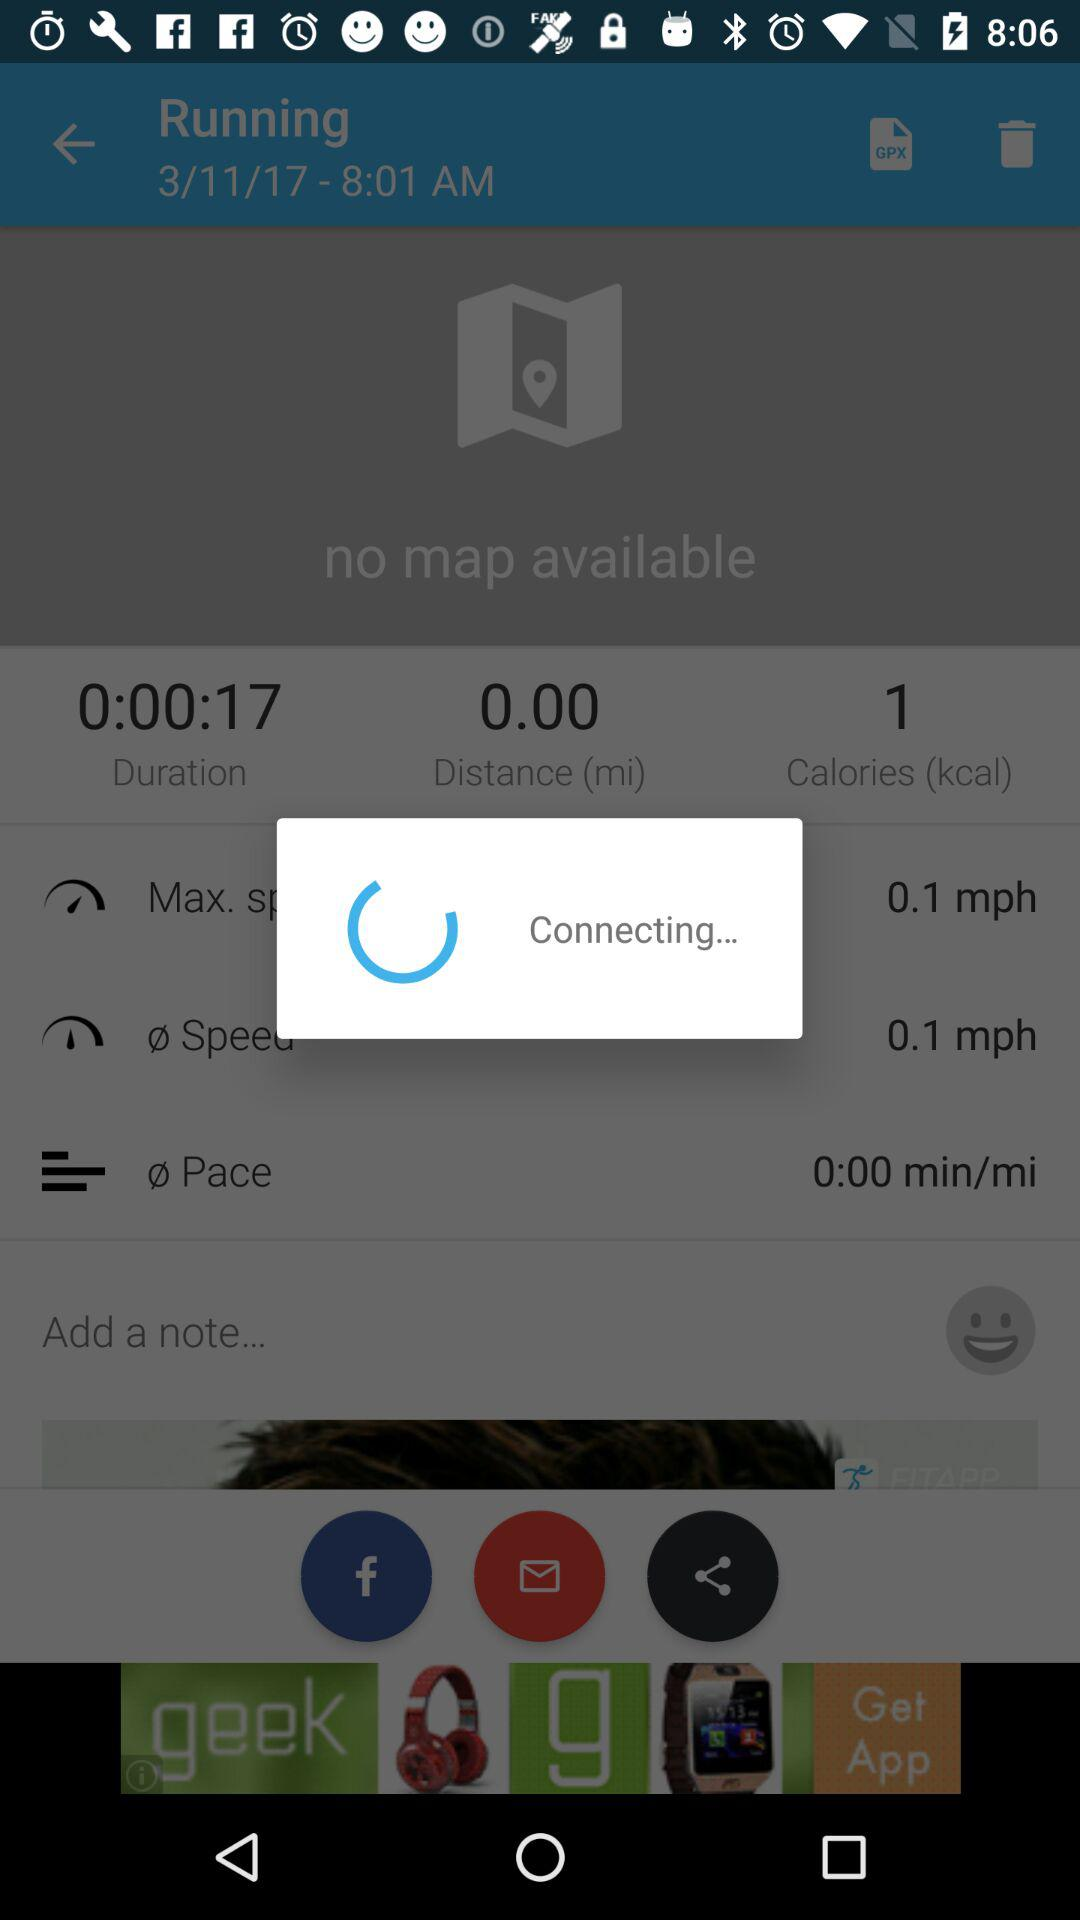What's the duration shown on the screen? The duration shown on the screen is 0:00:17. 